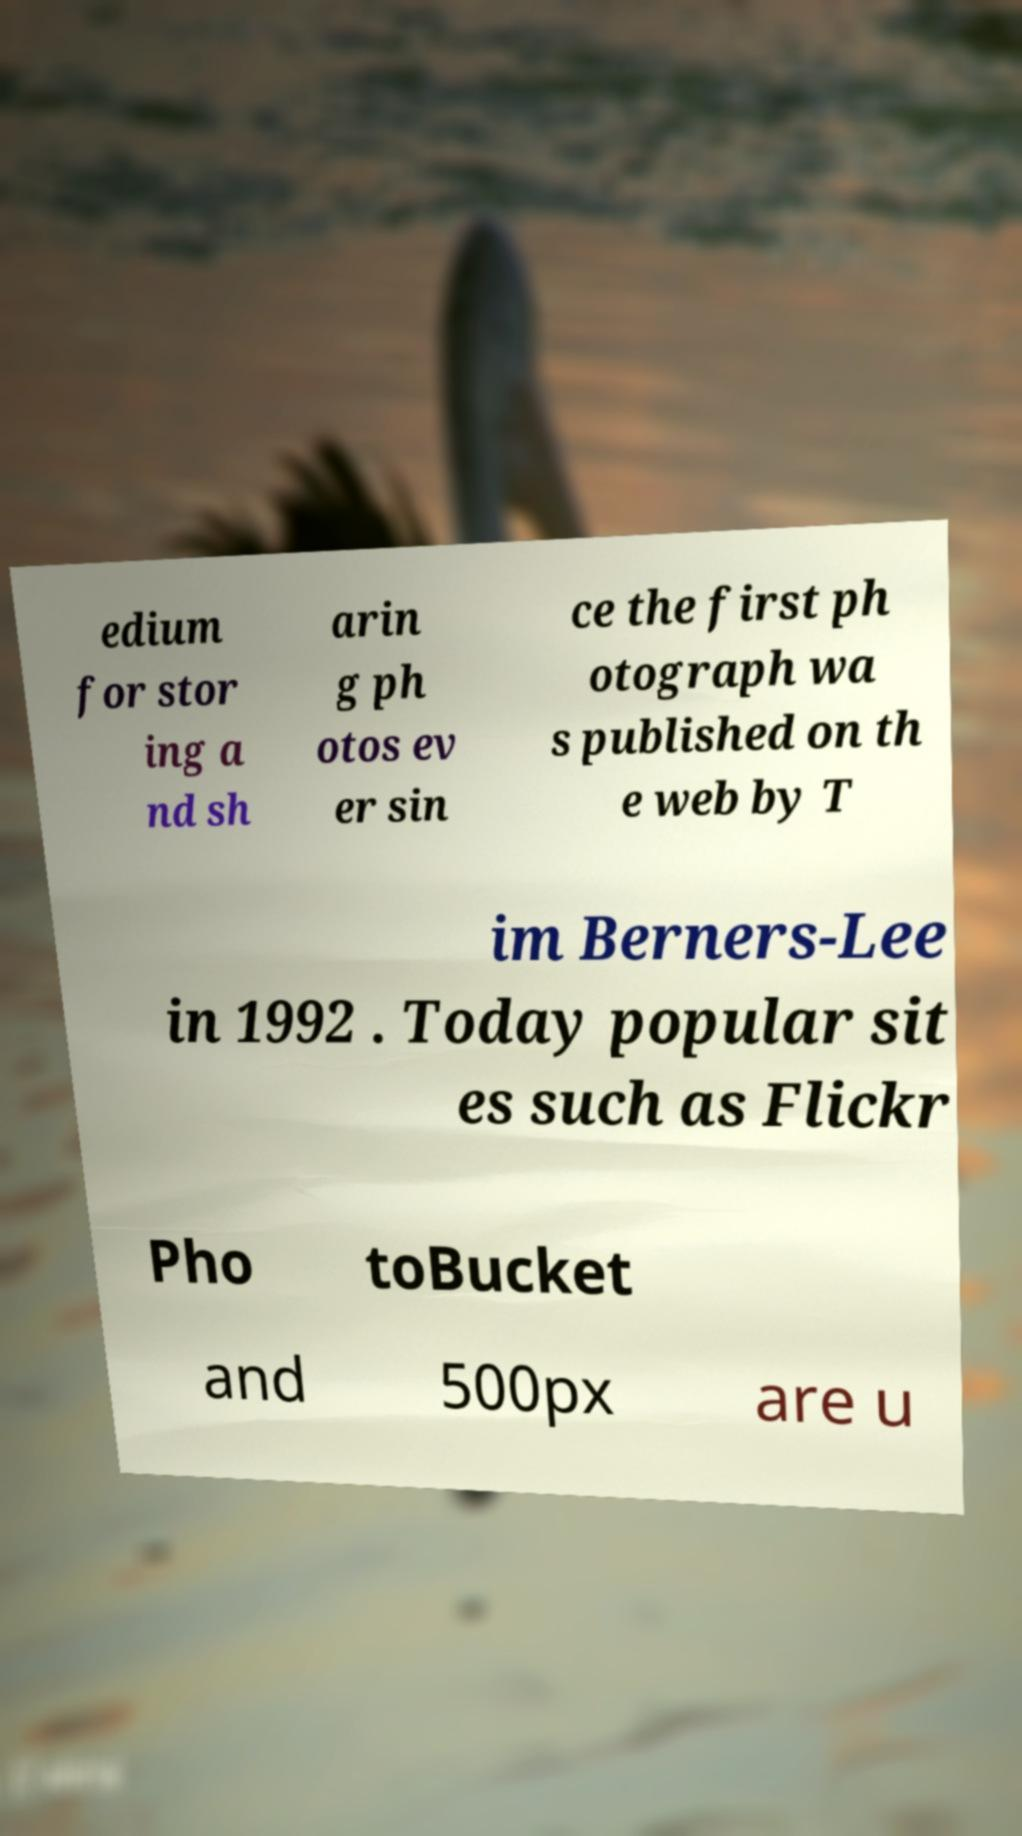Can you accurately transcribe the text from the provided image for me? edium for stor ing a nd sh arin g ph otos ev er sin ce the first ph otograph wa s published on th e web by T im Berners-Lee in 1992 . Today popular sit es such as Flickr Pho toBucket and 500px are u 